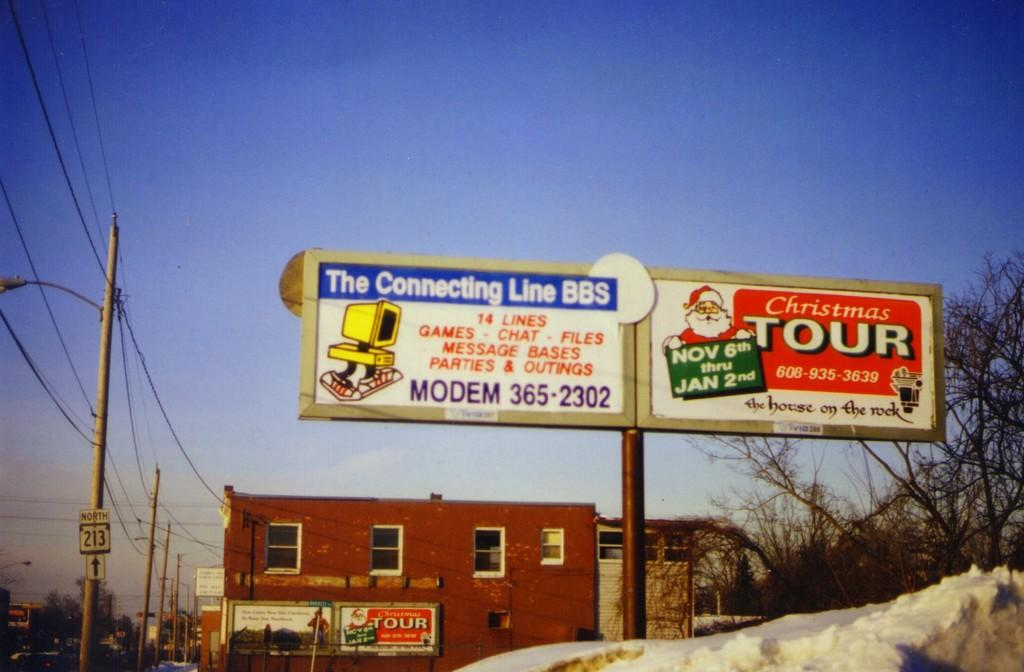<image>
Share a concise interpretation of the image provided. A billboard for a Christmas Tour sits above a snowy holltop 